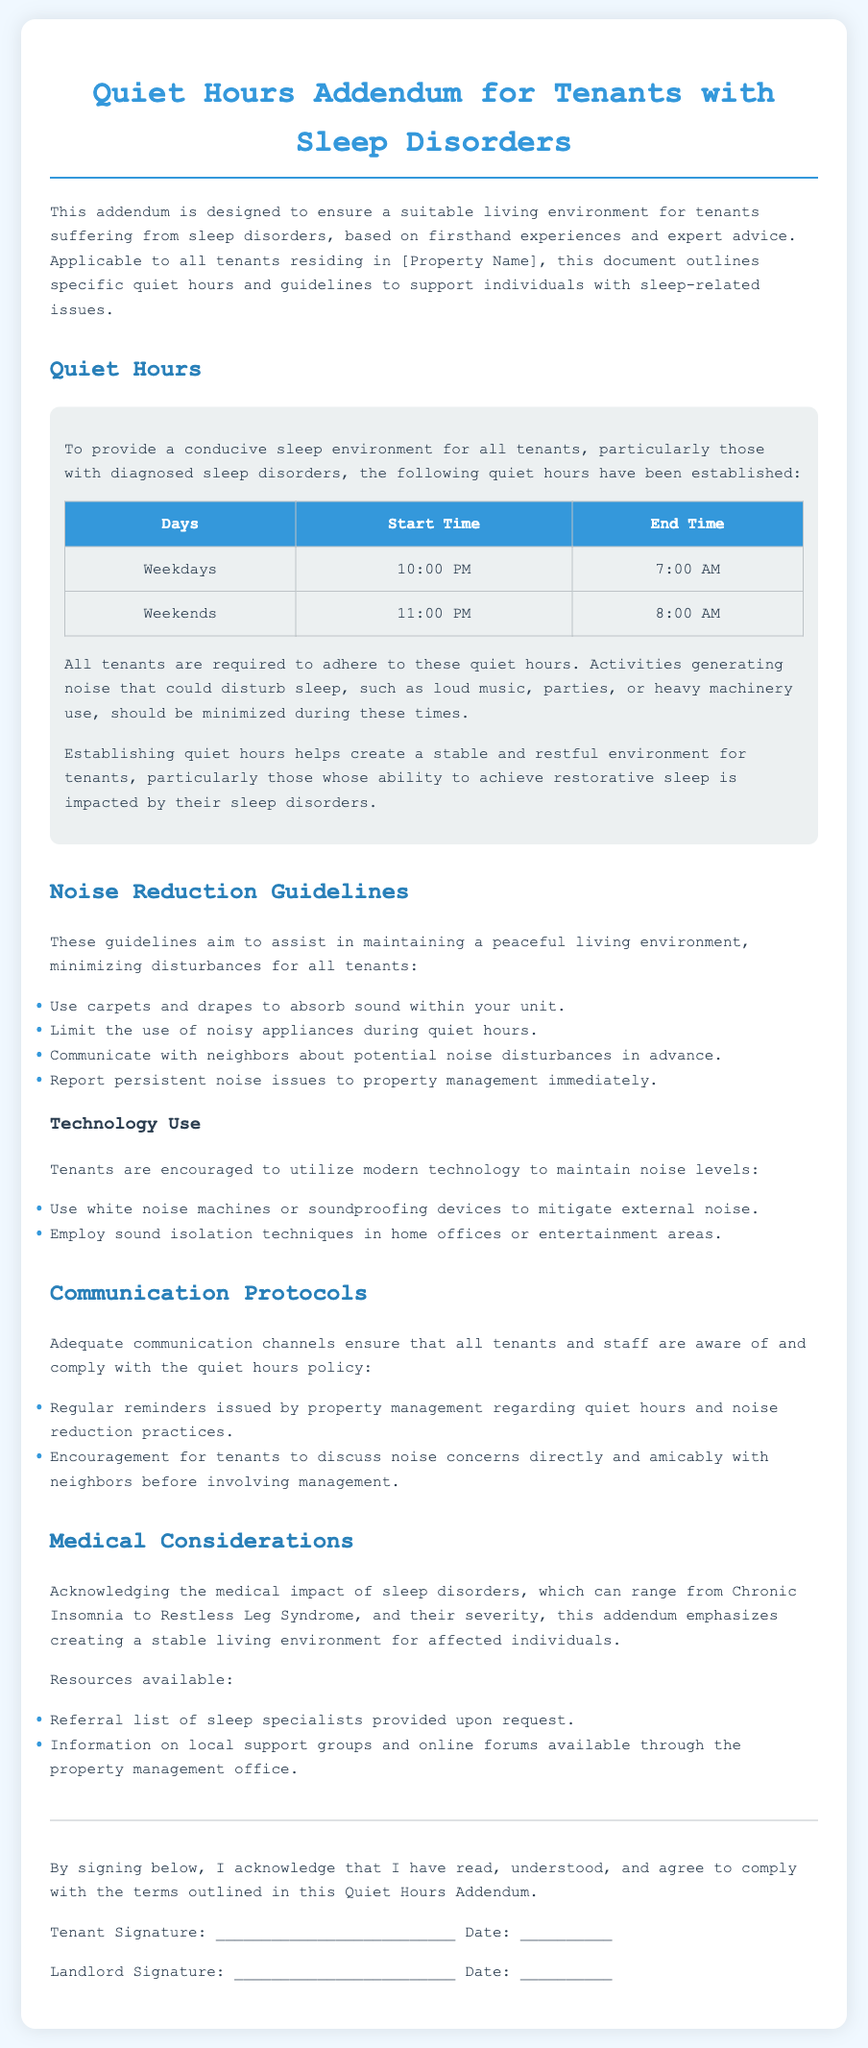What are the quiet hours for weekdays? The quiet hours for weekdays are from 10:00 PM to 7:00 AM.
Answer: 10:00 PM to 7:00 AM What activities should be minimized during quiet hours? Activities generating noise that could disturb sleep should be minimized during quiet hours, such as loud music or parties.
Answer: Loud music, parties What is the start time for quiet hours on weekends? The start time for quiet hours on weekends is listed in the document.
Answer: 11:00 PM What technology is recommended to mitigate external noise? The document suggests using white noise machines or soundproofing devices to mitigate external noise.
Answer: White noise machines How often will property management issue reminders about quiet hours? The document indicates regular reminders will be issued by property management.
Answer: Regularly What are tenants encouraged to discuss with their neighbors? The document suggests tenants discuss noise concerns directly and amicably with neighbors before involving management.
Answer: Noise concerns What should tenants use to absorb sound within their units? The document recommends using carpets and drapes to absorb sound within tenants' units.
Answer: Carpets and drapes What type of list can tenants request for sleep specialists? The document mentions a referral list of sleep specialists is provided upon request.
Answer: Referral list What should tenants do if they encounter persistent noise issues? The document states that tenants should report persistent noise issues to property management immediately.
Answer: Report to management 